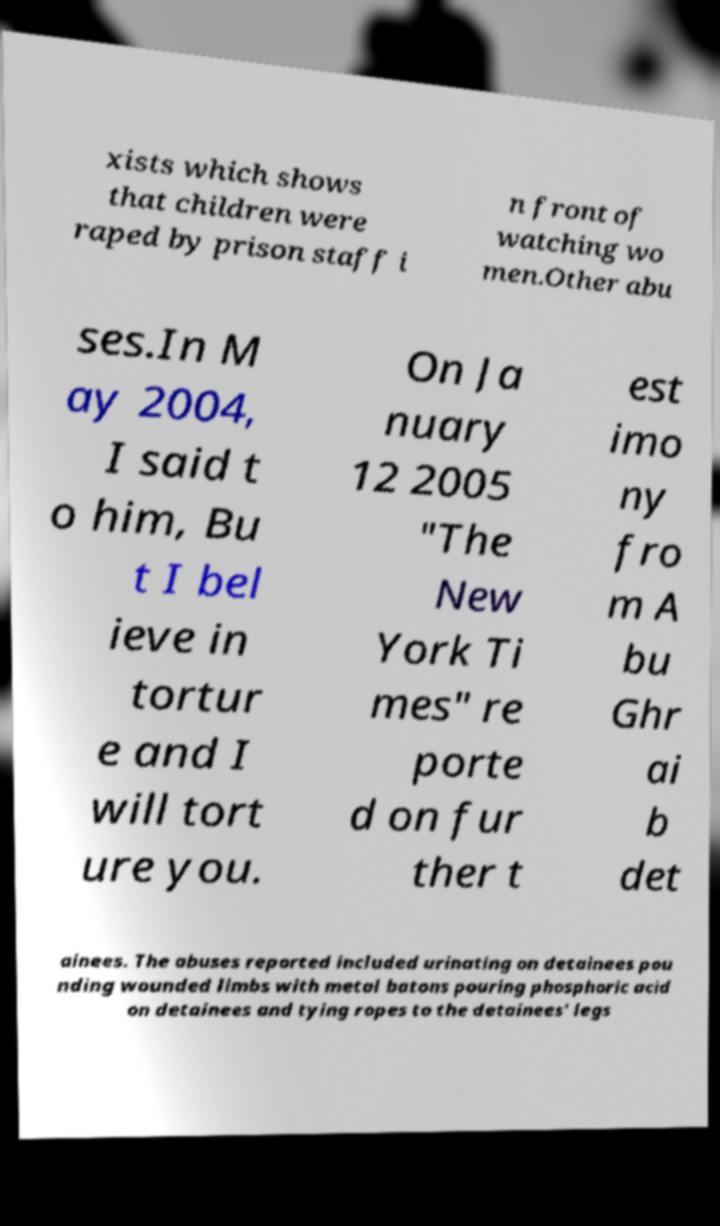For documentation purposes, I need the text within this image transcribed. Could you provide that? xists which shows that children were raped by prison staff i n front of watching wo men.Other abu ses.In M ay 2004, I said t o him, Bu t I bel ieve in tortur e and I will tort ure you. On Ja nuary 12 2005 "The New York Ti mes" re porte d on fur ther t est imo ny fro m A bu Ghr ai b det ainees. The abuses reported included urinating on detainees pou nding wounded limbs with metal batons pouring phosphoric acid on detainees and tying ropes to the detainees' legs 